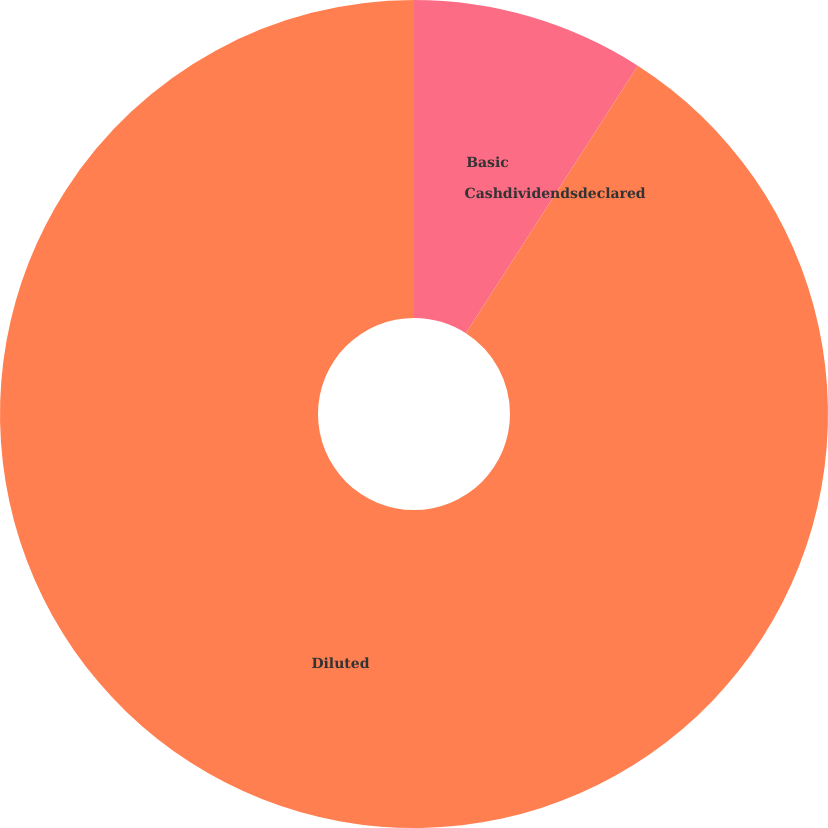<chart> <loc_0><loc_0><loc_500><loc_500><pie_chart><fcel>Basic<fcel>Cashdividendsdeclared<fcel>Diluted<nl><fcel>9.09%<fcel>0.0%<fcel>90.91%<nl></chart> 